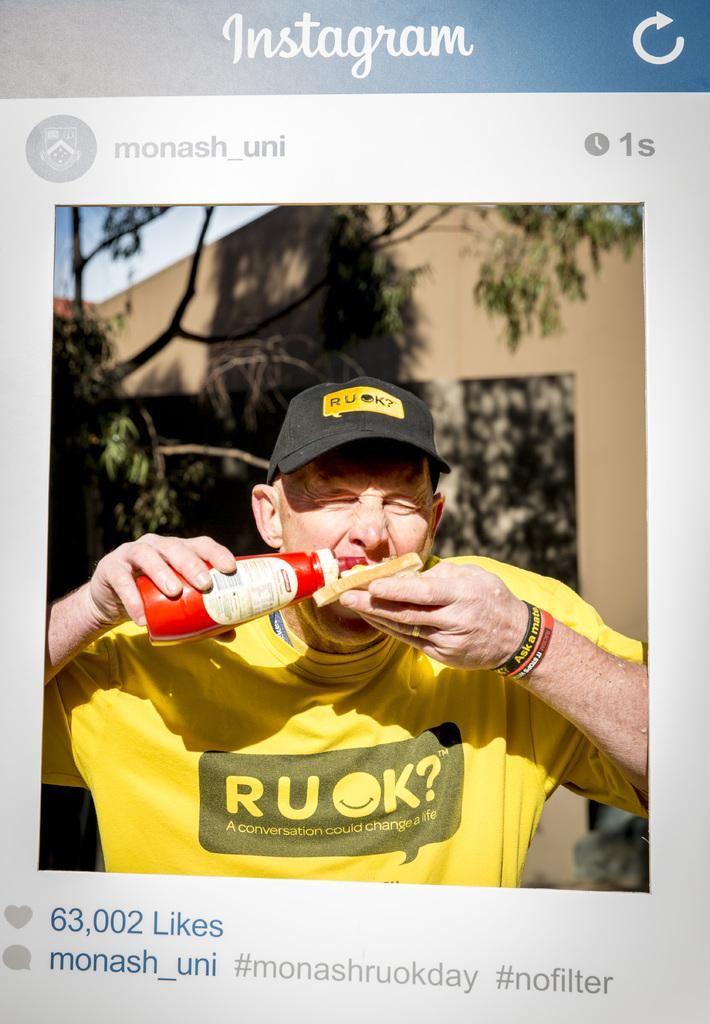<image>
Write a terse but informative summary of the picture. An Instagram post of a man eating and that was posted one second ago. 